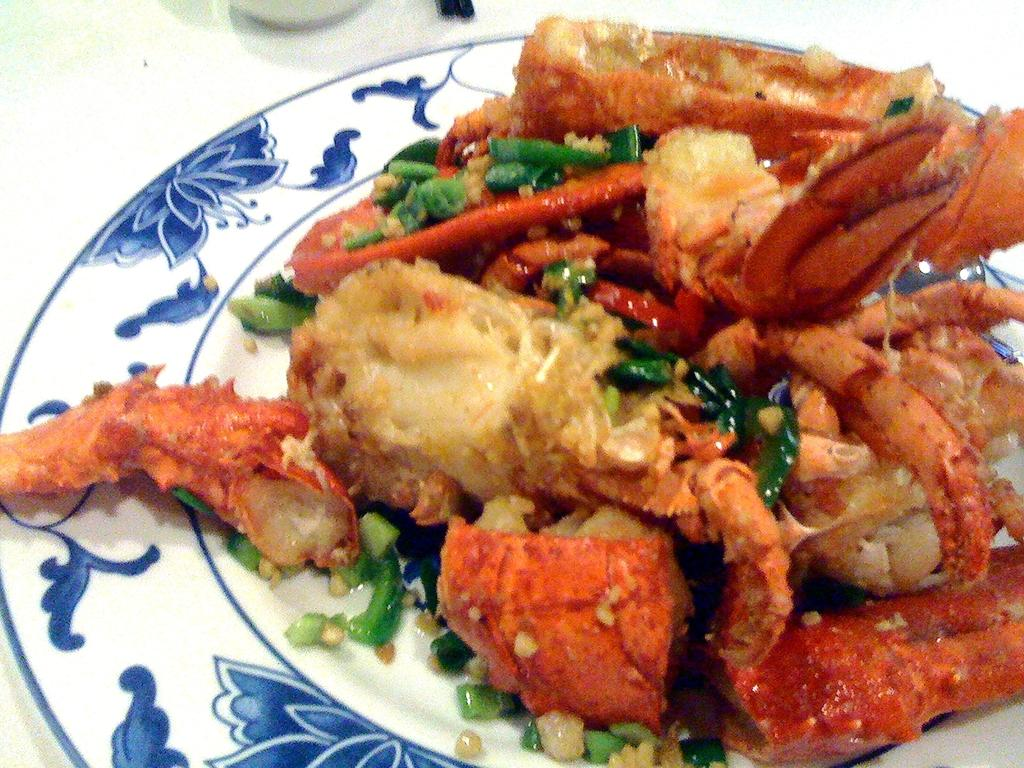What is the main object in the center of the image? There is a plate in the center of the image. What is on the plate? The plate contains food items. What type of actor can be seen performing on the plate in the image? There is no actor present in the image; it only contains food items on a plate. 